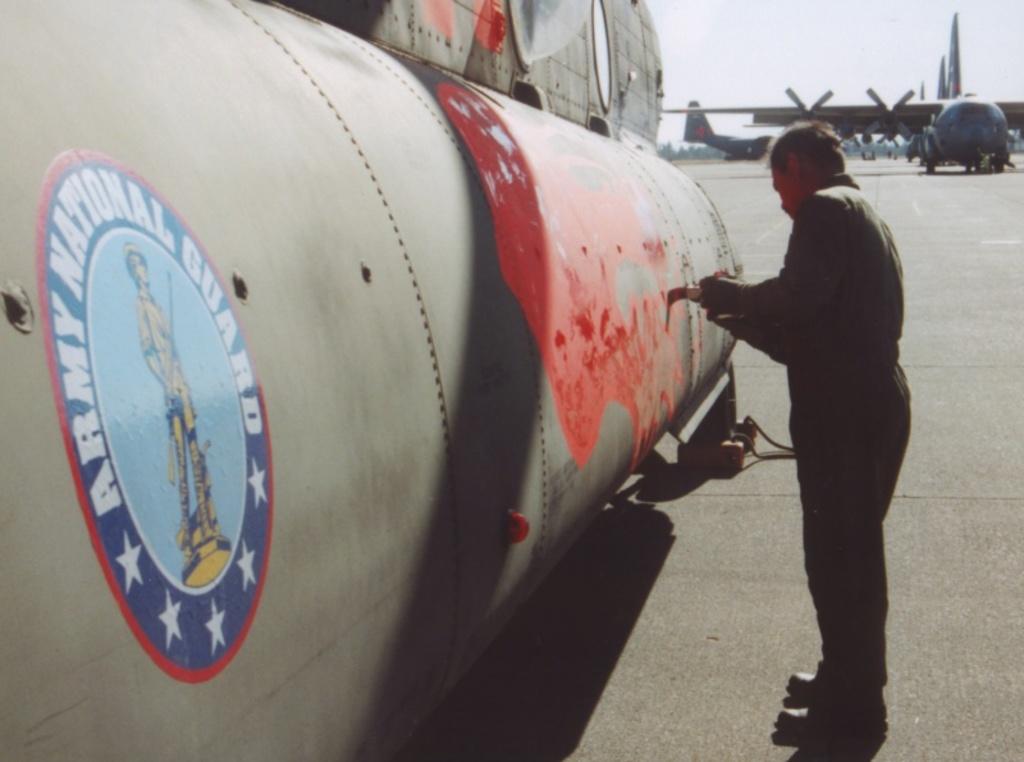What branch of the service does the emblem represent?
Your answer should be very brief. Army national guard. 